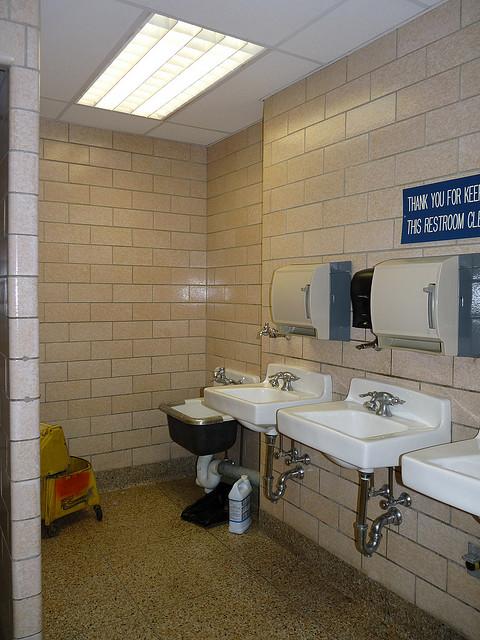Is the skylight so that users can tan themselves?
Be succinct. No. Is there more than one sink?
Keep it brief. Yes. Is this a public restroom?
Write a very short answer. Yes. 